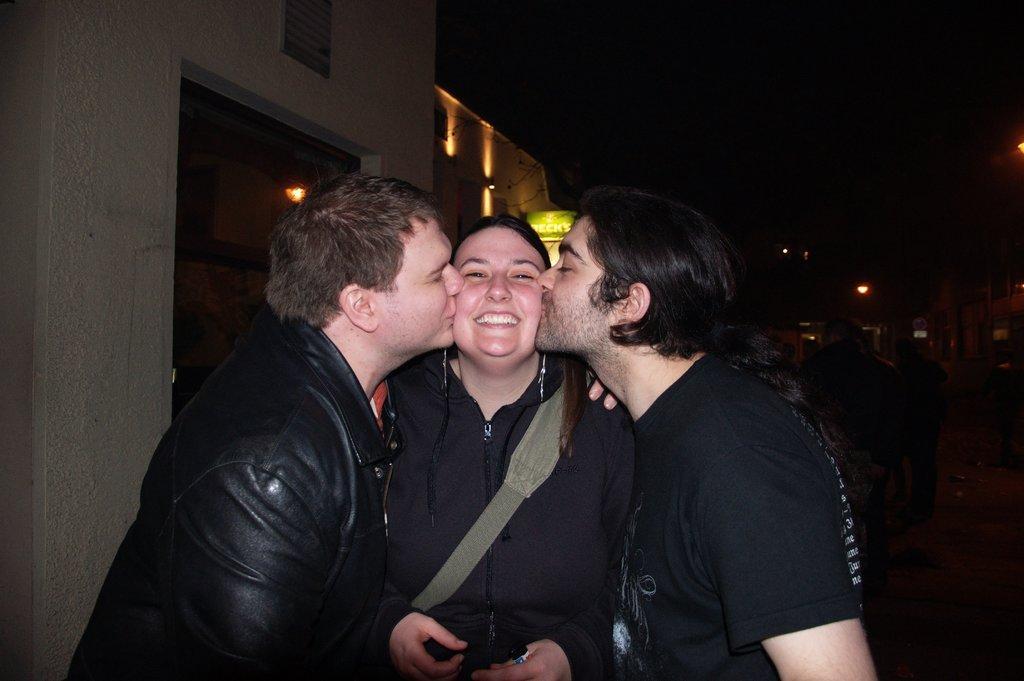Can you describe this image briefly? this picture two men and a woman both the men kissing woman on her cheeks and we see a smile on her face we see couple of buildings 